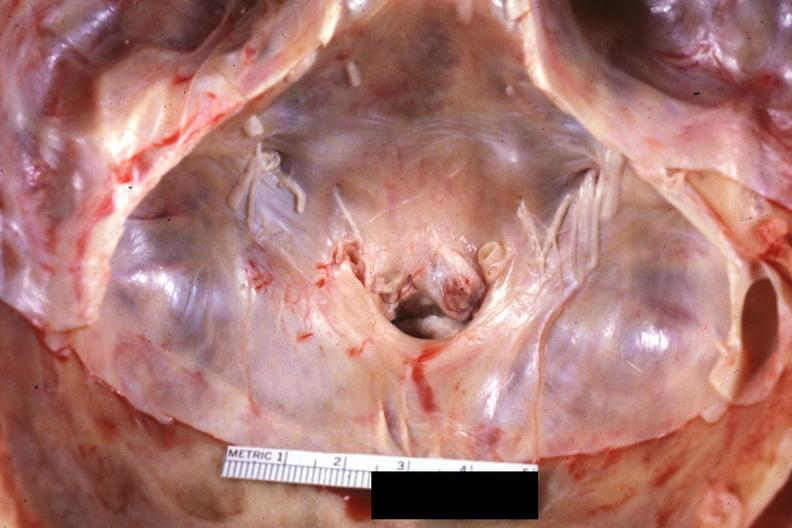what is present?
Answer the question using a single word or phrase. Rheumatoid arthritis 